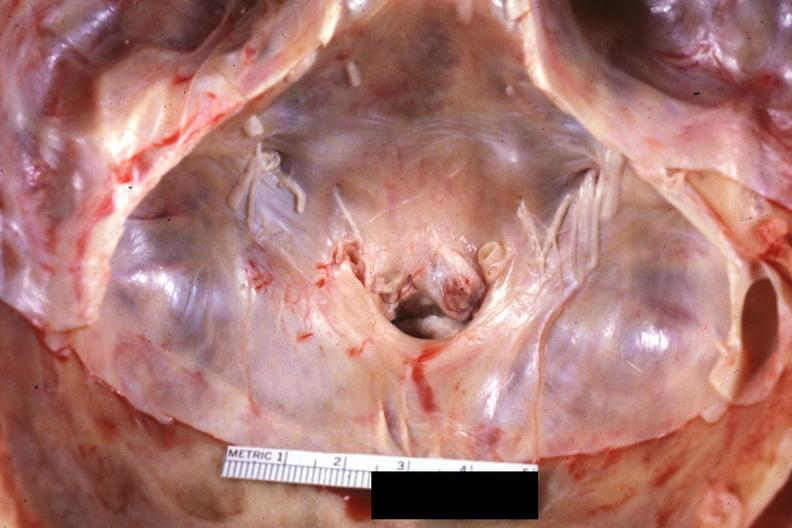what is present?
Answer the question using a single word or phrase. Rheumatoid arthritis 